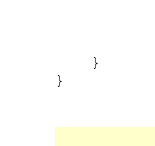Convert code to text. <code><loc_0><loc_0><loc_500><loc_500><_Kotlin_>    }
}
</code> 